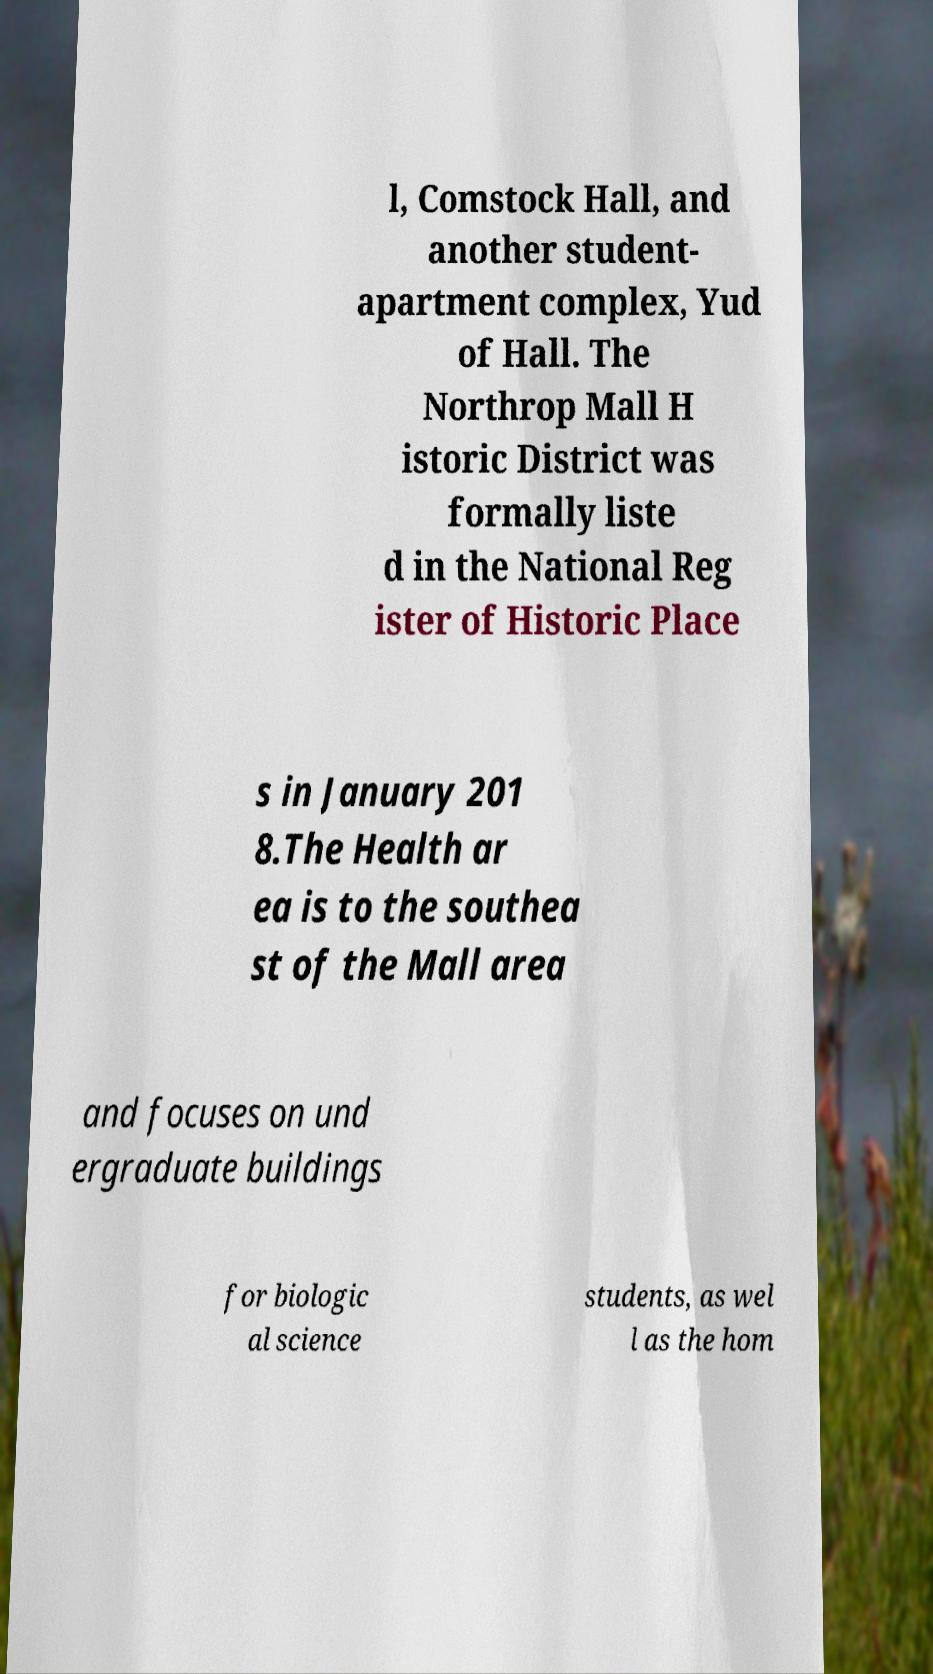Can you accurately transcribe the text from the provided image for me? l, Comstock Hall, and another student- apartment complex, Yud of Hall. The Northrop Mall H istoric District was formally liste d in the National Reg ister of Historic Place s in January 201 8.The Health ar ea is to the southea st of the Mall area and focuses on und ergraduate buildings for biologic al science students, as wel l as the hom 